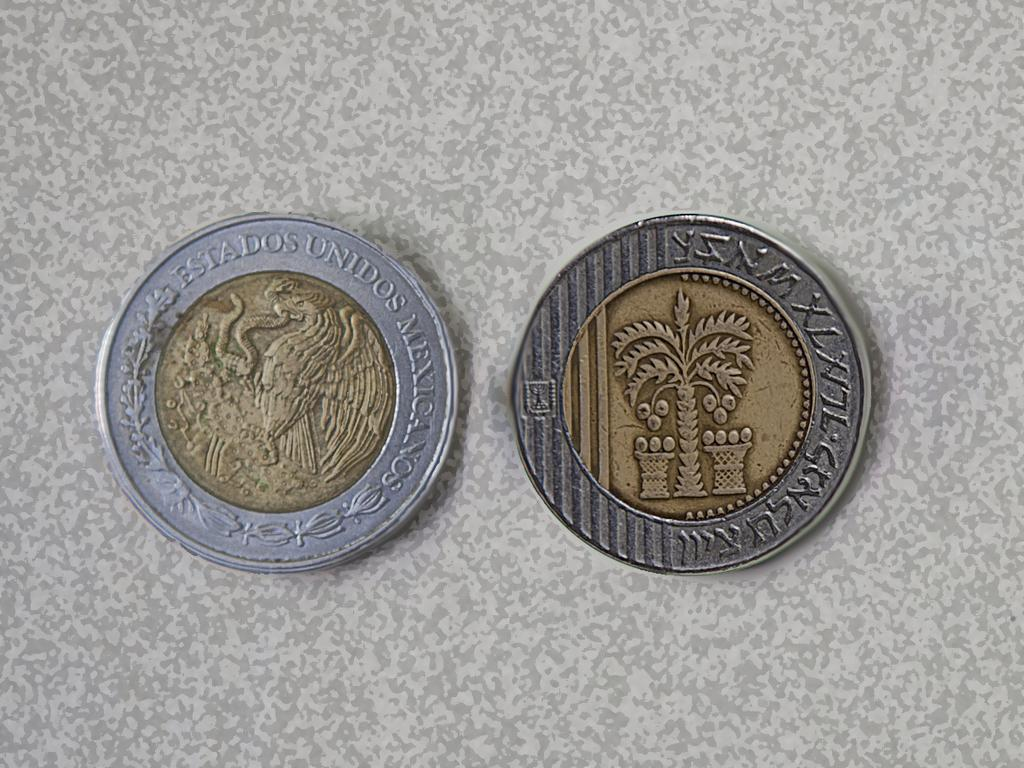<image>
Write a terse but informative summary of the picture. A two-toned coin has the word Mexicanos on one side. 